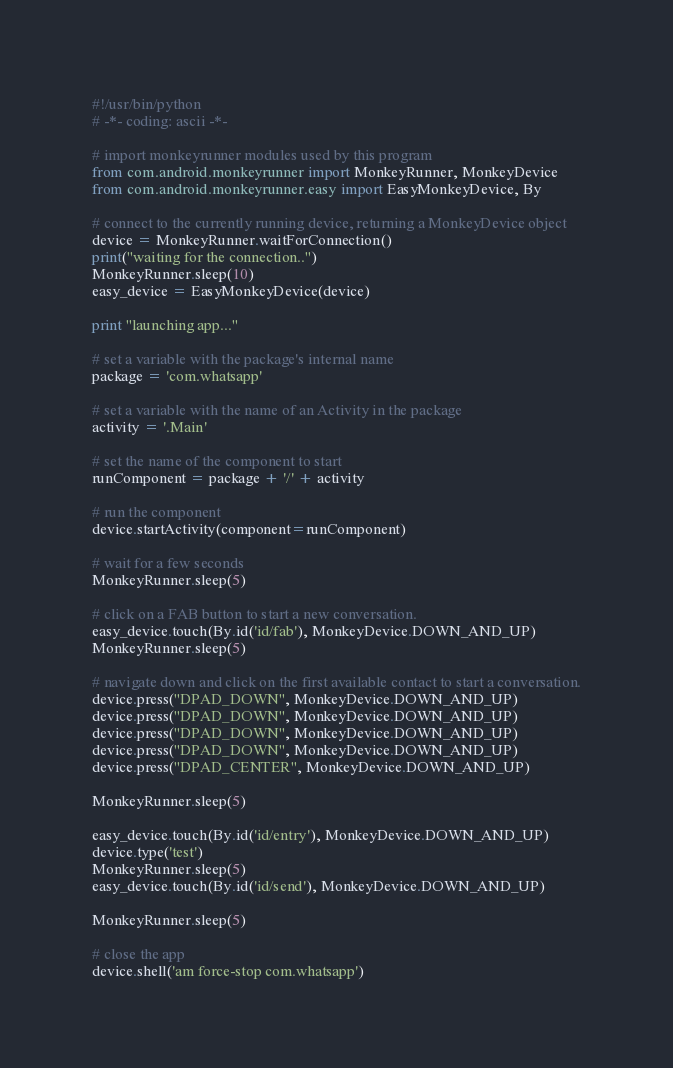<code> <loc_0><loc_0><loc_500><loc_500><_Python_>#!/usr/bin/python
# -*- coding: ascii -*-

# import monkeyrunner modules used by this program
from com.android.monkeyrunner import MonkeyRunner, MonkeyDevice
from com.android.monkeyrunner.easy import EasyMonkeyDevice, By

# connect to the currently running device, returning a MonkeyDevice object
device = MonkeyRunner.waitForConnection()
print("waiting for the connection..")
MonkeyRunner.sleep(10)
easy_device = EasyMonkeyDevice(device)

print "launching app..."

# set a variable with the package's internal name
package = 'com.whatsapp'

# set a variable with the name of an Activity in the package
activity = '.Main'

# set the name of the component to start
runComponent = package + '/' + activity

# run the component
device.startActivity(component=runComponent)

# wait for a few seconds
MonkeyRunner.sleep(5)

# click on a FAB button to start a new conversation.
easy_device.touch(By.id('id/fab'), MonkeyDevice.DOWN_AND_UP)
MonkeyRunner.sleep(5)

# navigate down and click on the first available contact to start a conversation.
device.press("DPAD_DOWN", MonkeyDevice.DOWN_AND_UP)
device.press("DPAD_DOWN", MonkeyDevice.DOWN_AND_UP)
device.press("DPAD_DOWN", MonkeyDevice.DOWN_AND_UP)
device.press("DPAD_DOWN", MonkeyDevice.DOWN_AND_UP)
device.press("DPAD_CENTER", MonkeyDevice.DOWN_AND_UP)

MonkeyRunner.sleep(5)

easy_device.touch(By.id('id/entry'), MonkeyDevice.DOWN_AND_UP)
device.type('test')
MonkeyRunner.sleep(5)
easy_device.touch(By.id('id/send'), MonkeyDevice.DOWN_AND_UP)

MonkeyRunner.sleep(5)

# close the app
device.shell('am force-stop com.whatsapp')

</code> 